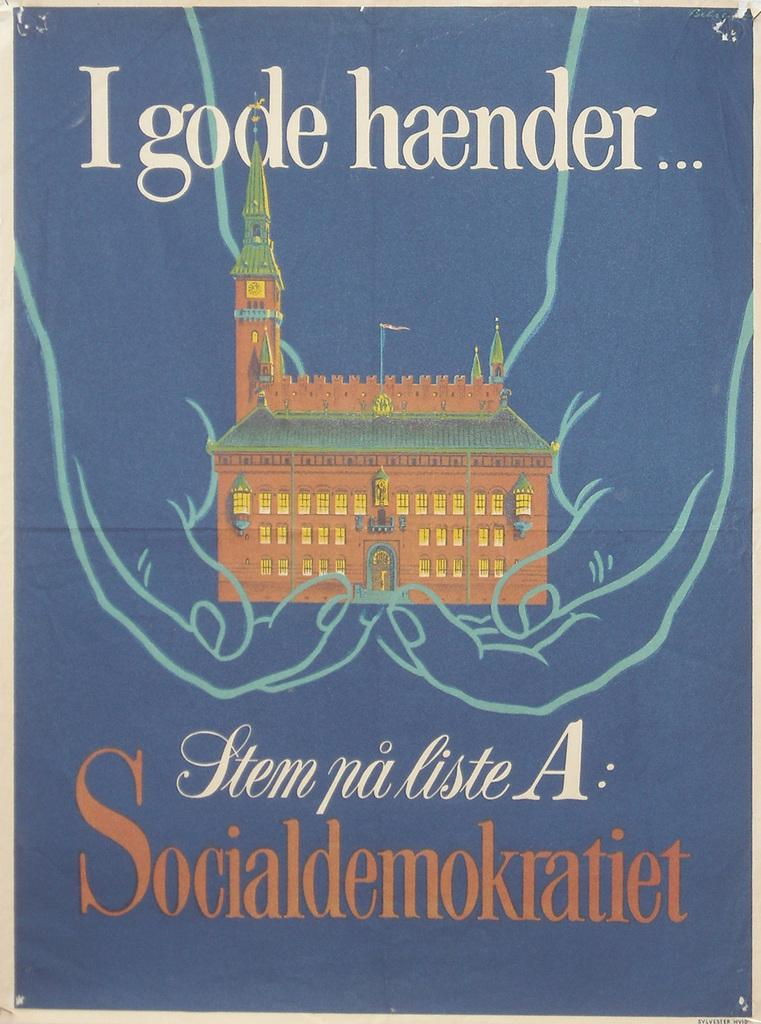<image>
Create a compact narrative representing the image presented. A book cover with a building on it and I gode haender... written above it. 